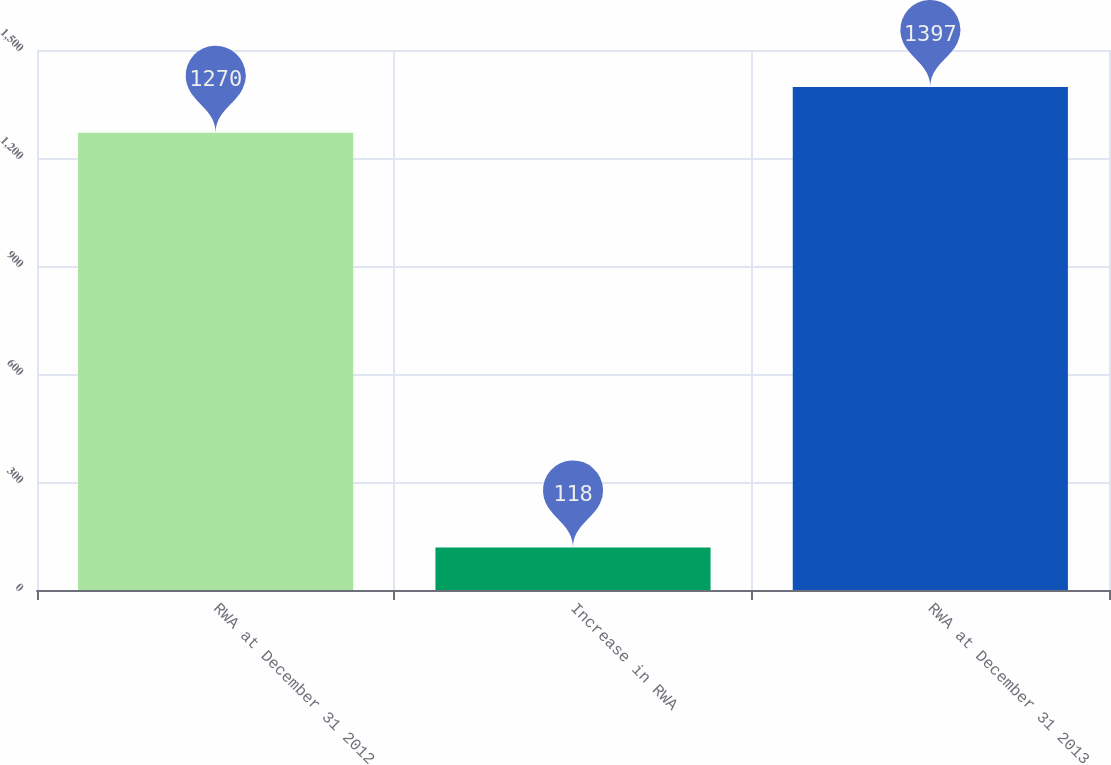Convert chart. <chart><loc_0><loc_0><loc_500><loc_500><bar_chart><fcel>RWA at December 31 2012<fcel>Increase in RWA<fcel>RWA at December 31 2013<nl><fcel>1270<fcel>118<fcel>1397<nl></chart> 